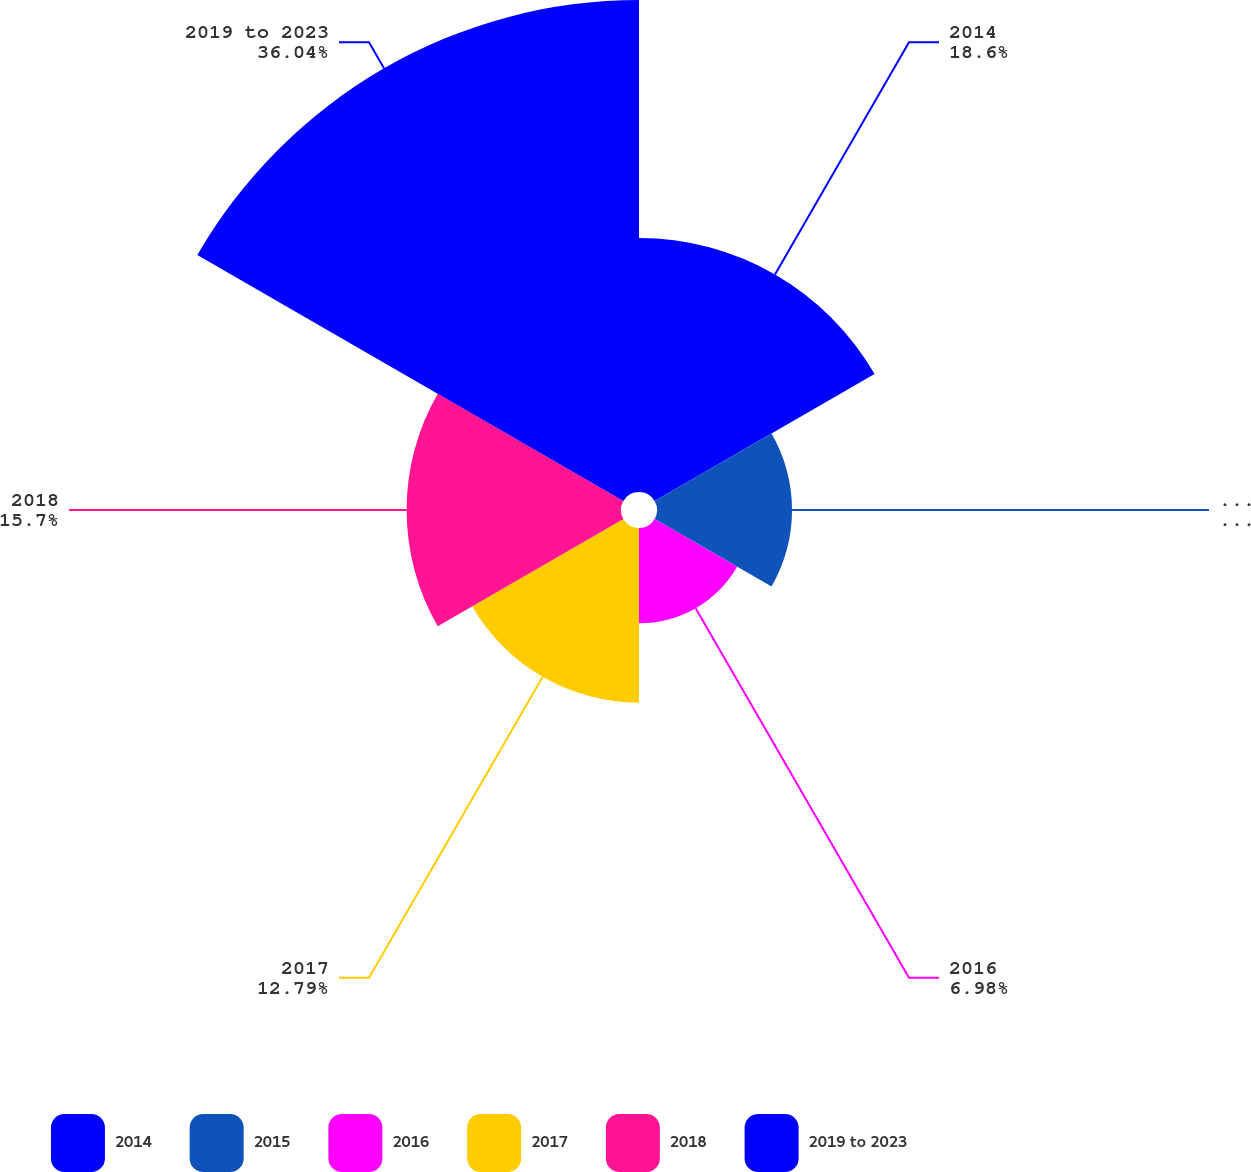<chart> <loc_0><loc_0><loc_500><loc_500><pie_chart><fcel>2014<fcel>2015<fcel>2016<fcel>2017<fcel>2018<fcel>2019 to 2023<nl><fcel>18.6%<fcel>9.89%<fcel>6.98%<fcel>12.79%<fcel>15.7%<fcel>36.03%<nl></chart> 